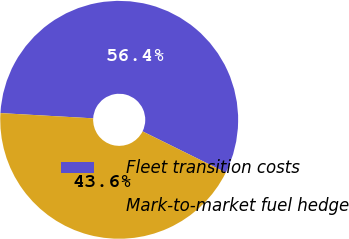Convert chart to OTSL. <chart><loc_0><loc_0><loc_500><loc_500><pie_chart><fcel>Fleet transition costs<fcel>Mark-to-market fuel hedge<nl><fcel>56.41%<fcel>43.59%<nl></chart> 